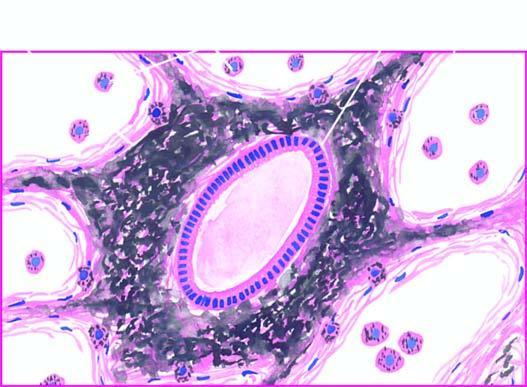s the interstitial vasculature presence of abundant coarse black carbon pigment in the septal walls and around the bronchiole?
Answer the question using a single word or phrase. No 